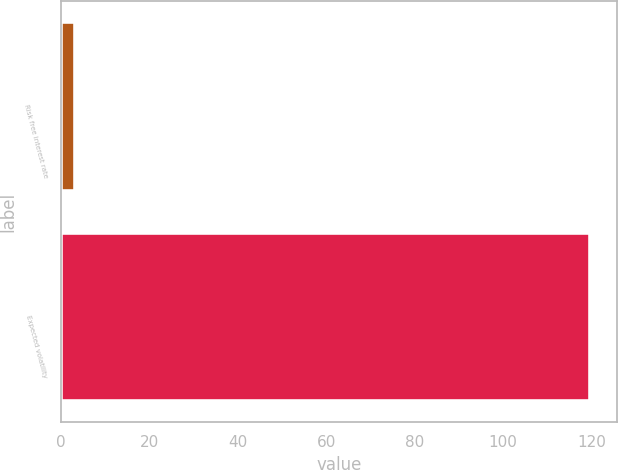Convert chart to OTSL. <chart><loc_0><loc_0><loc_500><loc_500><bar_chart><fcel>Risk free interest rate<fcel>Expected volatility<nl><fcel>3.03<fcel>119.8<nl></chart> 